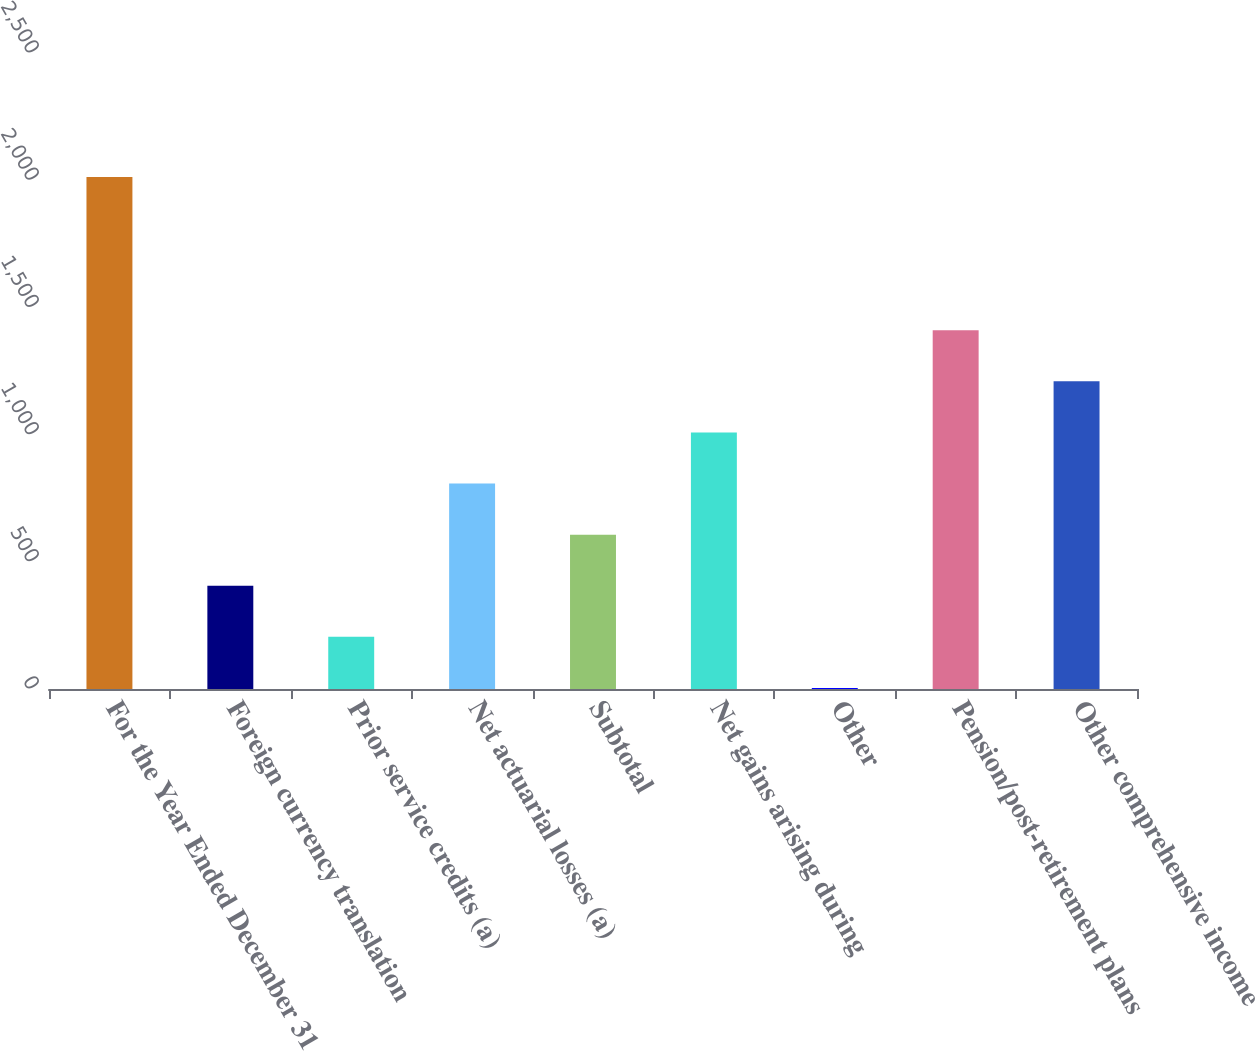Convert chart to OTSL. <chart><loc_0><loc_0><loc_500><loc_500><bar_chart><fcel>For the Year Ended December 31<fcel>Foreign currency translation<fcel>Prior service credits (a)<fcel>Net actuarial losses (a)<fcel>Subtotal<fcel>Net gains arising during<fcel>Other<fcel>Pension/post-retirement plans<fcel>Other comprehensive income<nl><fcel>2013<fcel>405.8<fcel>204.9<fcel>807.6<fcel>606.7<fcel>1008.5<fcel>4<fcel>1410.3<fcel>1209.4<nl></chart> 